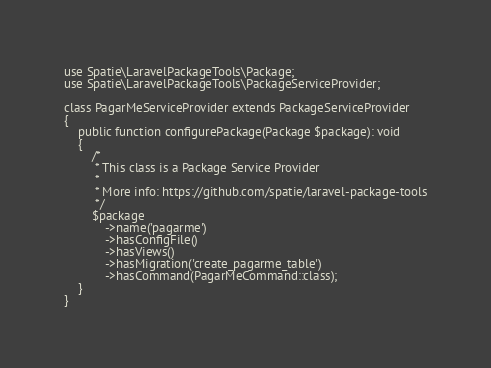Convert code to text. <code><loc_0><loc_0><loc_500><loc_500><_PHP_>use Spatie\LaravelPackageTools\Package;
use Spatie\LaravelPackageTools\PackageServiceProvider;

class PagarMeServiceProvider extends PackageServiceProvider
{
    public function configurePackage(Package $package): void
    {
        /*
         * This class is a Package Service Provider
         *
         * More info: https://github.com/spatie/laravel-package-tools
         */
        $package
            ->name('pagarme')
            ->hasConfigFile()
            ->hasViews()
            ->hasMigration('create_pagarme_table')
            ->hasCommand(PagarMeCommand::class);
    }
}
</code> 